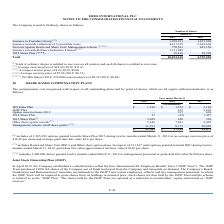According to Eros International Plc's financial document, What is the amount of options granted towards Share Plans in 2019? According to the financial document, 1,305,399. The relevant text states: "(*) includes of 1,305,399 options granted towards Share Plan 2015 during twelve months ended March 31, 2019 at an average exe..." Also, What are the fiscal years included in the table? The document contains multiple relevant values: 2019, 2018, 2017. From the document: "2019 2018 2017 2019 2018 2017 2019 2018 2017..." Also, What is the IPO India Plan value in 2019? According to the financial document, $1,198 (in thousands). The relevant text states: "IPO India Plan $ 1,198 $ 1,572 $ 2,140..." Also, How many fiscal years had  IPO India Plan above $2,000 thousand? Based on the analysis, there are 1 instances. The counting process: 2017. Additionally, Which fiscal year had the greatest total compensation cost? According to the financial document, 2017. The relevant text states: "2019 2018 2017..." Additionally, Which fiscal year had the lowest Management scheme (staff share grant) compensation costs? According to the financial document, 2018. The relevant text states: "2019 2018 2017..." 